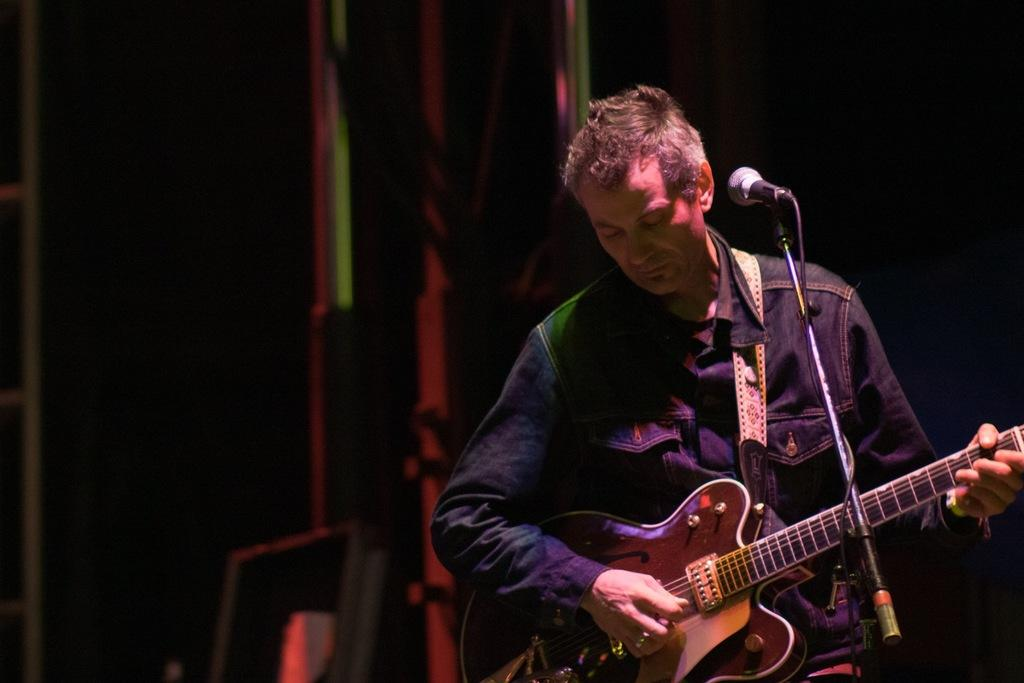What is the man in the image doing? The man is playing a guitar in the image. How is the man playing the guitar? The man is using his hands to play the guitar. What object is in front of the man? There is a microphone in front of the man. What type of fiction book is the man reading while playing the guitar? There is no book present in the image, and the man is not reading while playing the guitar. 